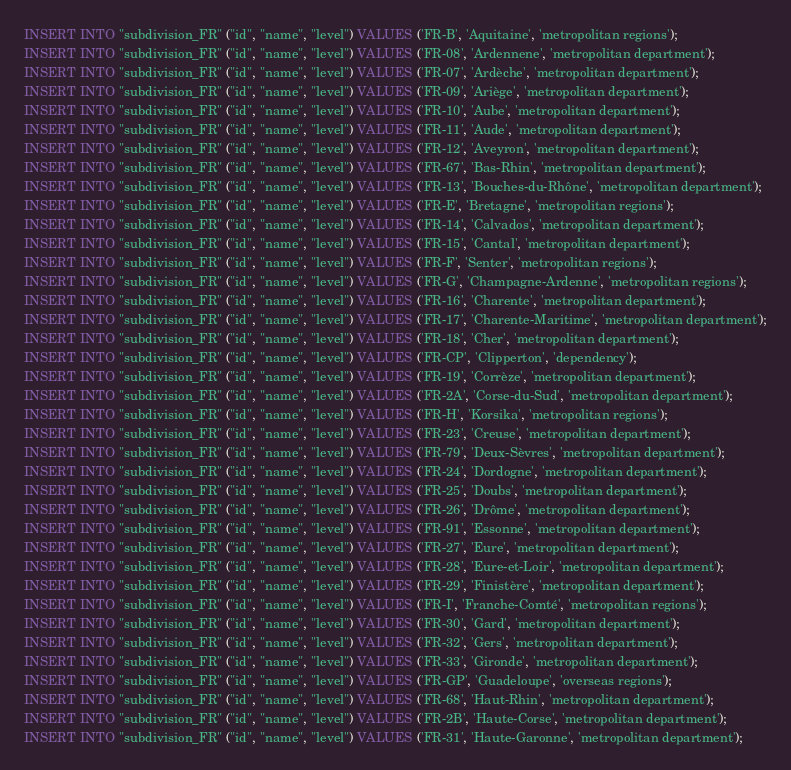<code> <loc_0><loc_0><loc_500><loc_500><_SQL_>INSERT INTO "subdivision_FR" ("id", "name", "level") VALUES ('FR-B', 'Aquitaine', 'metropolitan regions');
INSERT INTO "subdivision_FR" ("id", "name", "level") VALUES ('FR-08', 'Ardennene', 'metropolitan department');
INSERT INTO "subdivision_FR" ("id", "name", "level") VALUES ('FR-07', 'Ardèche', 'metropolitan department');
INSERT INTO "subdivision_FR" ("id", "name", "level") VALUES ('FR-09', 'Ariège', 'metropolitan department');
INSERT INTO "subdivision_FR" ("id", "name", "level") VALUES ('FR-10', 'Aube', 'metropolitan department');
INSERT INTO "subdivision_FR" ("id", "name", "level") VALUES ('FR-11', 'Aude', 'metropolitan department');
INSERT INTO "subdivision_FR" ("id", "name", "level") VALUES ('FR-12', 'Aveyron', 'metropolitan department');
INSERT INTO "subdivision_FR" ("id", "name", "level") VALUES ('FR-67', 'Bas-Rhin', 'metropolitan department');
INSERT INTO "subdivision_FR" ("id", "name", "level") VALUES ('FR-13', 'Bouches-du-Rhône', 'metropolitan department');
INSERT INTO "subdivision_FR" ("id", "name", "level") VALUES ('FR-E', 'Bretagne', 'metropolitan regions');
INSERT INTO "subdivision_FR" ("id", "name", "level") VALUES ('FR-14', 'Calvados', 'metropolitan department');
INSERT INTO "subdivision_FR" ("id", "name", "level") VALUES ('FR-15', 'Cantal', 'metropolitan department');
INSERT INTO "subdivision_FR" ("id", "name", "level") VALUES ('FR-F', 'Senter', 'metropolitan regions');
INSERT INTO "subdivision_FR" ("id", "name", "level") VALUES ('FR-G', 'Champagne-Ardenne', 'metropolitan regions');
INSERT INTO "subdivision_FR" ("id", "name", "level") VALUES ('FR-16', 'Charente', 'metropolitan department');
INSERT INTO "subdivision_FR" ("id", "name", "level") VALUES ('FR-17', 'Charente-Maritime', 'metropolitan department');
INSERT INTO "subdivision_FR" ("id", "name", "level") VALUES ('FR-18', 'Cher', 'metropolitan department');
INSERT INTO "subdivision_FR" ("id", "name", "level") VALUES ('FR-CP', 'Clipperton', 'dependency');
INSERT INTO "subdivision_FR" ("id", "name", "level") VALUES ('FR-19', 'Corrèze', 'metropolitan department');
INSERT INTO "subdivision_FR" ("id", "name", "level") VALUES ('FR-2A', 'Corse-du-Sud', 'metropolitan department');
INSERT INTO "subdivision_FR" ("id", "name", "level") VALUES ('FR-H', 'Korsika', 'metropolitan regions');
INSERT INTO "subdivision_FR" ("id", "name", "level") VALUES ('FR-23', 'Creuse', 'metropolitan department');
INSERT INTO "subdivision_FR" ("id", "name", "level") VALUES ('FR-79', 'Deux-Sèvres', 'metropolitan department');
INSERT INTO "subdivision_FR" ("id", "name", "level") VALUES ('FR-24', 'Dordogne', 'metropolitan department');
INSERT INTO "subdivision_FR" ("id", "name", "level") VALUES ('FR-25', 'Doubs', 'metropolitan department');
INSERT INTO "subdivision_FR" ("id", "name", "level") VALUES ('FR-26', 'Drôme', 'metropolitan department');
INSERT INTO "subdivision_FR" ("id", "name", "level") VALUES ('FR-91', 'Essonne', 'metropolitan department');
INSERT INTO "subdivision_FR" ("id", "name", "level") VALUES ('FR-27', 'Eure', 'metropolitan department');
INSERT INTO "subdivision_FR" ("id", "name", "level") VALUES ('FR-28', 'Eure-et-Loir', 'metropolitan department');
INSERT INTO "subdivision_FR" ("id", "name", "level") VALUES ('FR-29', 'Finistère', 'metropolitan department');
INSERT INTO "subdivision_FR" ("id", "name", "level") VALUES ('FR-I', 'Franche-Comté', 'metropolitan regions');
INSERT INTO "subdivision_FR" ("id", "name", "level") VALUES ('FR-30', 'Gard', 'metropolitan department');
INSERT INTO "subdivision_FR" ("id", "name", "level") VALUES ('FR-32', 'Gers', 'metropolitan department');
INSERT INTO "subdivision_FR" ("id", "name", "level") VALUES ('FR-33', 'Gironde', 'metropolitan department');
INSERT INTO "subdivision_FR" ("id", "name", "level") VALUES ('FR-GP', 'Guadeloupe', 'overseas regions');
INSERT INTO "subdivision_FR" ("id", "name", "level") VALUES ('FR-68', 'Haut-Rhin', 'metropolitan department');
INSERT INTO "subdivision_FR" ("id", "name", "level") VALUES ('FR-2B', 'Haute-Corse', 'metropolitan department');
INSERT INTO "subdivision_FR" ("id", "name", "level") VALUES ('FR-31', 'Haute-Garonne', 'metropolitan department');</code> 